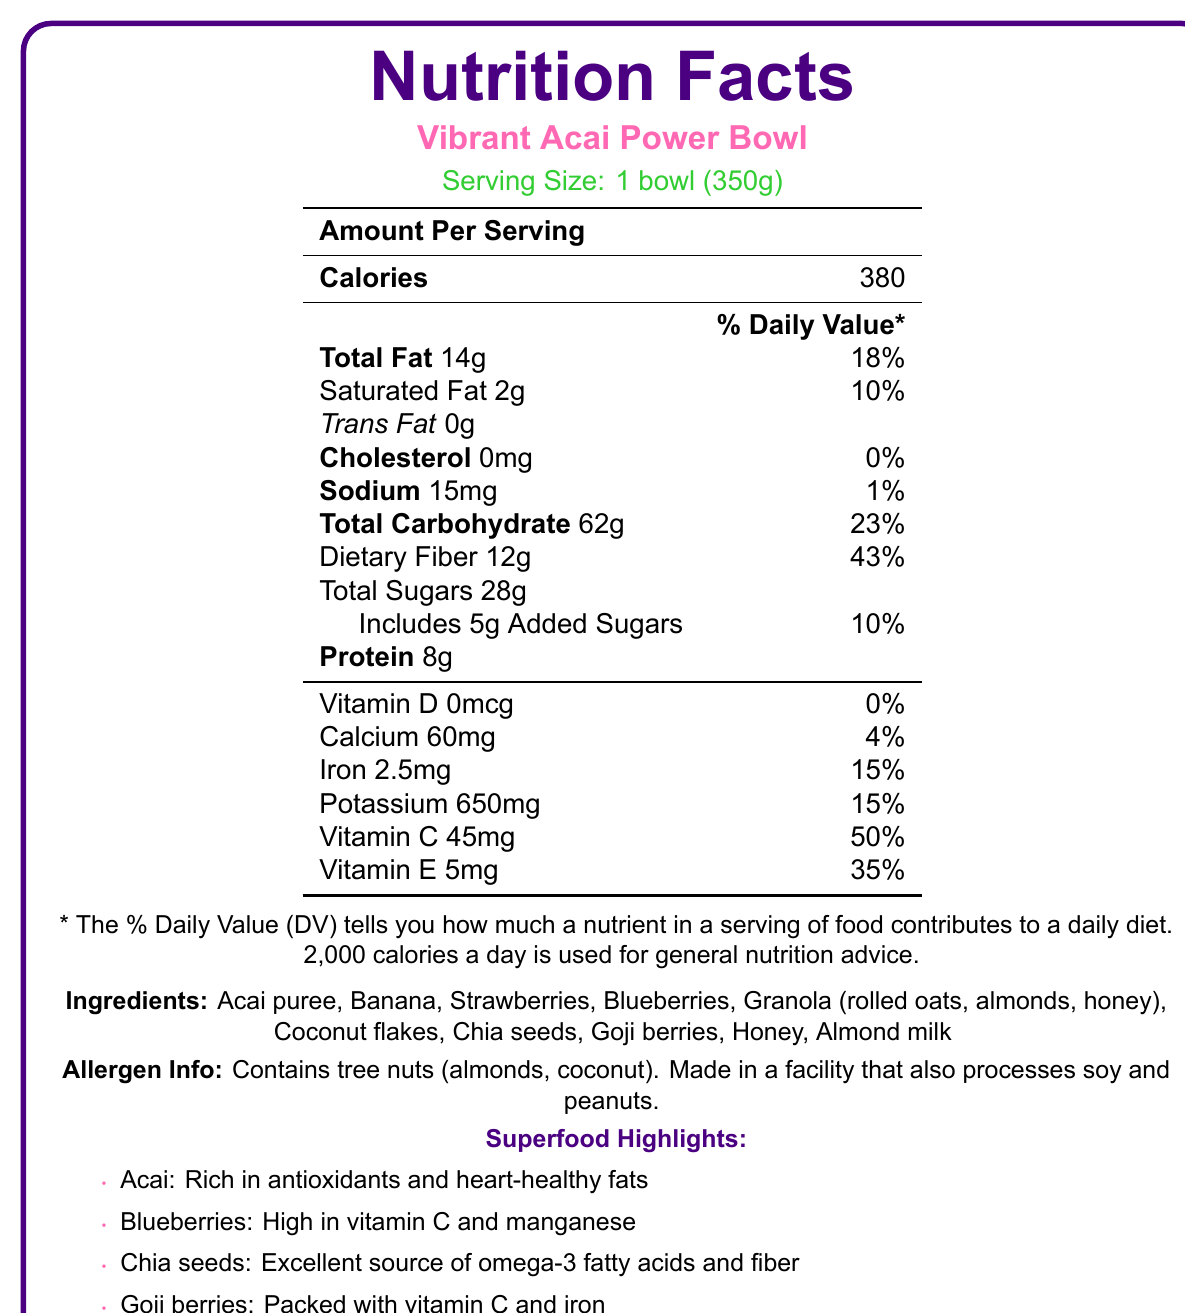What is the serving size for the Vibrant Acai Power Bowl? The serving size is explicitly mentioned as "1 bowl (350g)" in the document.
Answer: 1 bowl (350g) How many calories are in one serving of the Vibrant Acai Power Bowl? The number of calories per serving is listed as 380 in the document.
Answer: 380 How much dietary fiber does the Vibrant Acai Power Bowl contain? The document states that the total dietary fiber per serving is 12g.
Answer: 12g What is the % Daily Value of Vitamin C in the Vibrant Acai Power Bowl? The document indicates that the % Daily Value for Vitamin C is 50%.
Answer: 50% List three ingredients found in the Vibrant Acai Power Bowl. The ingredients section lists "Acai puree," "Banana," and "Strawberries" among other ingredients.
Answer: Acai puree, Banana, Strawberries Which of the following is not an ingredient in the Vibrant Acai Power Bowl? A. Acai puree B. Banana C. Spinach D. Coconut flakes The document lists the ingredients, and Spinach is not among them.
Answer: C. Spinach What is the main benefit of Acai according to the Superfood Highlights? A. High in vitamin C B. Rich in antioxidants and heart-healthy fats C. Packed with vitamin C and iron D. Excellent source of omega-3 fatty acids and fiber According to the Superfood Highlights, Acai is rich in antioxidants and heart-healthy fats.
Answer: B. Rich in antioxidants and heart-healthy fats What % Daily Value of iron does the Vibrant Acai Power Bowl provide? The document specifies that the % Daily Value for iron is 15%.
Answer: 15% True or False? The Vibrant Acai Power Bowl contains added sugars. The document states that it includes 5g of added sugars.
Answer: True Summarize the main idea of this Nutrition Facts Label. The document comprehensively covers nutritional data, ingredient list, superfood benefits, and allergen information for the Vibrant Acai Power Bowl.
Answer: The document provides the nutritional information for the Vibrant Acai Power Bowl, highlighting its serving size, calories, macronutrients, vitamins, minerals, ingredients, and superfood benefits. It details the high-fiber content, antioxidant-rich ingredients, and the allergen information including tree nuts. Can we determine the manufacturing location of the Vibrant Acai Power Bowl? The document does not provide any information about the location where the bowl is manufactured.
Answer: Cannot be determined 